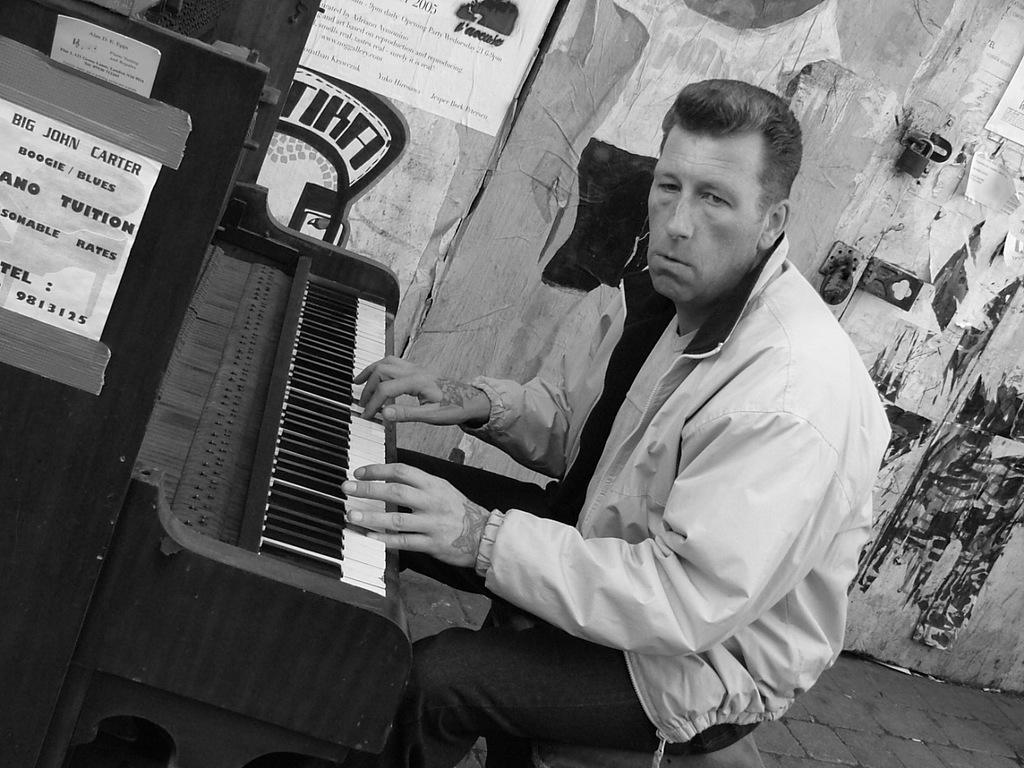Can you describe this image briefly? In this picture we can see a man sitting and playing piano in front of him and in background we can see wall with stickers, door, lock. 